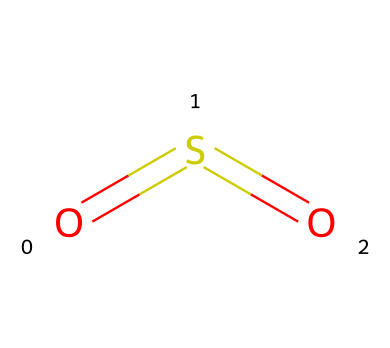What is the molecular formula of this compound? The SMILES representation indicates the presence of one sulfur (S) and two oxygen (O) atoms. Therefore, the molecular formula is derived from these atom counts.
Answer: SO2 How many bonds are present in this chemical structure? The structure has two double bonds: one between sulfur and each oxygen atom. Therefore, the total count of bonds is two.
Answer: 2 What type of bonding is shown between sulfur and oxygen in this compound? The presence of double bonds between sulfur and oxygen suggests that the bonding is covalent in nature, specifically double covalent bonds.
Answer: double covalent What is the hybridization state of sulfur in this compound? The sulfur atom is bonded to two oxygen atoms through double bonds, indicating that sulfur is hybridized in the sp form, where one s orbital and one p orbital combine.
Answer: sp How does sulfur dioxide contribute to acid rain? Sulfur dioxide reacts with water in the atmosphere to form sulfuric acid, which is a major component of acid rain. This shows the compound's role in contributing to environmental issues.
Answer: sulfuric acid Is sulfur dioxide a gas at room temperature? At room temperature, sulfur dioxide exists as a gas, confirming its state as a volatile compound.
Answer: gas What is the color of sulfur dioxide? Sulfur dioxide is colorless, which is indicative of its physical properties in the gaseous state.
Answer: colorless 